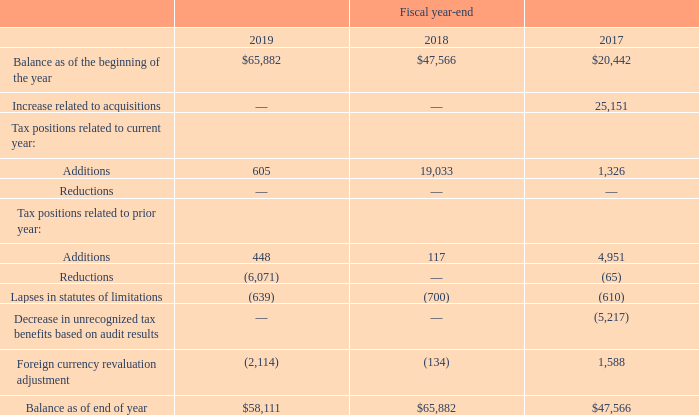A reconciliation of the change in gross unrecognized tax benefits, excluding interest and penalties,
is as follows (in thousands):
As of September 28, 2019, the total amount of gross unrecognized tax benefits including gross interest and penalties was $63.9 million, of which $43.9 million, if recognized, would affect our effective tax rate. We reassessed the computation of the transition tax liability based upon the issuance of new guidance and the availability of additional substantiation in fiscal 2019. The adjustments resulted in a tax benefit of approximately $6.0 million, which was recorded in fiscal 2019. Our total gross unrecognized tax benefit, net of certain deferred tax assets is classified as a long-term taxes payable in the consolidated balance sheets. We include interest and penalties related to unrecognized tax benefits within the provision for income taxes. As of September 28, 2019, the total amount of gross interest and penalties accrued was $5.8 million and it is classified as long-term taxes payable in the consolidated balance sheets. As of September 29, 2018, we had accrued $4.4 million for the gross interest and penalties and it is classified as Other long-term liabilities in the consolidated balance sheets.
What was the Balance as of end of year in 2019?
Answer scale should be: thousand. $58,111. What was the  Balance as of the beginning of the year  in 2018?
Answer scale should be: thousand. $47,566. In which years was the Balance as of end of year calculated? 2019, 2018, 2017. In which year was the Balance as of the beginning of the year the largest? 65,882>47,566>20,442
Answer: 2019. What was the change in Balance as of the beginning of the year in 2019 from 2018?
Answer scale should be: thousand. 65,882-47,566
Answer: 18316. What was the percentage change in Balance as of the beginning of the year in 2019 from 2018?
Answer scale should be: percent. (65,882-47,566)/47,566
Answer: 38.51. 